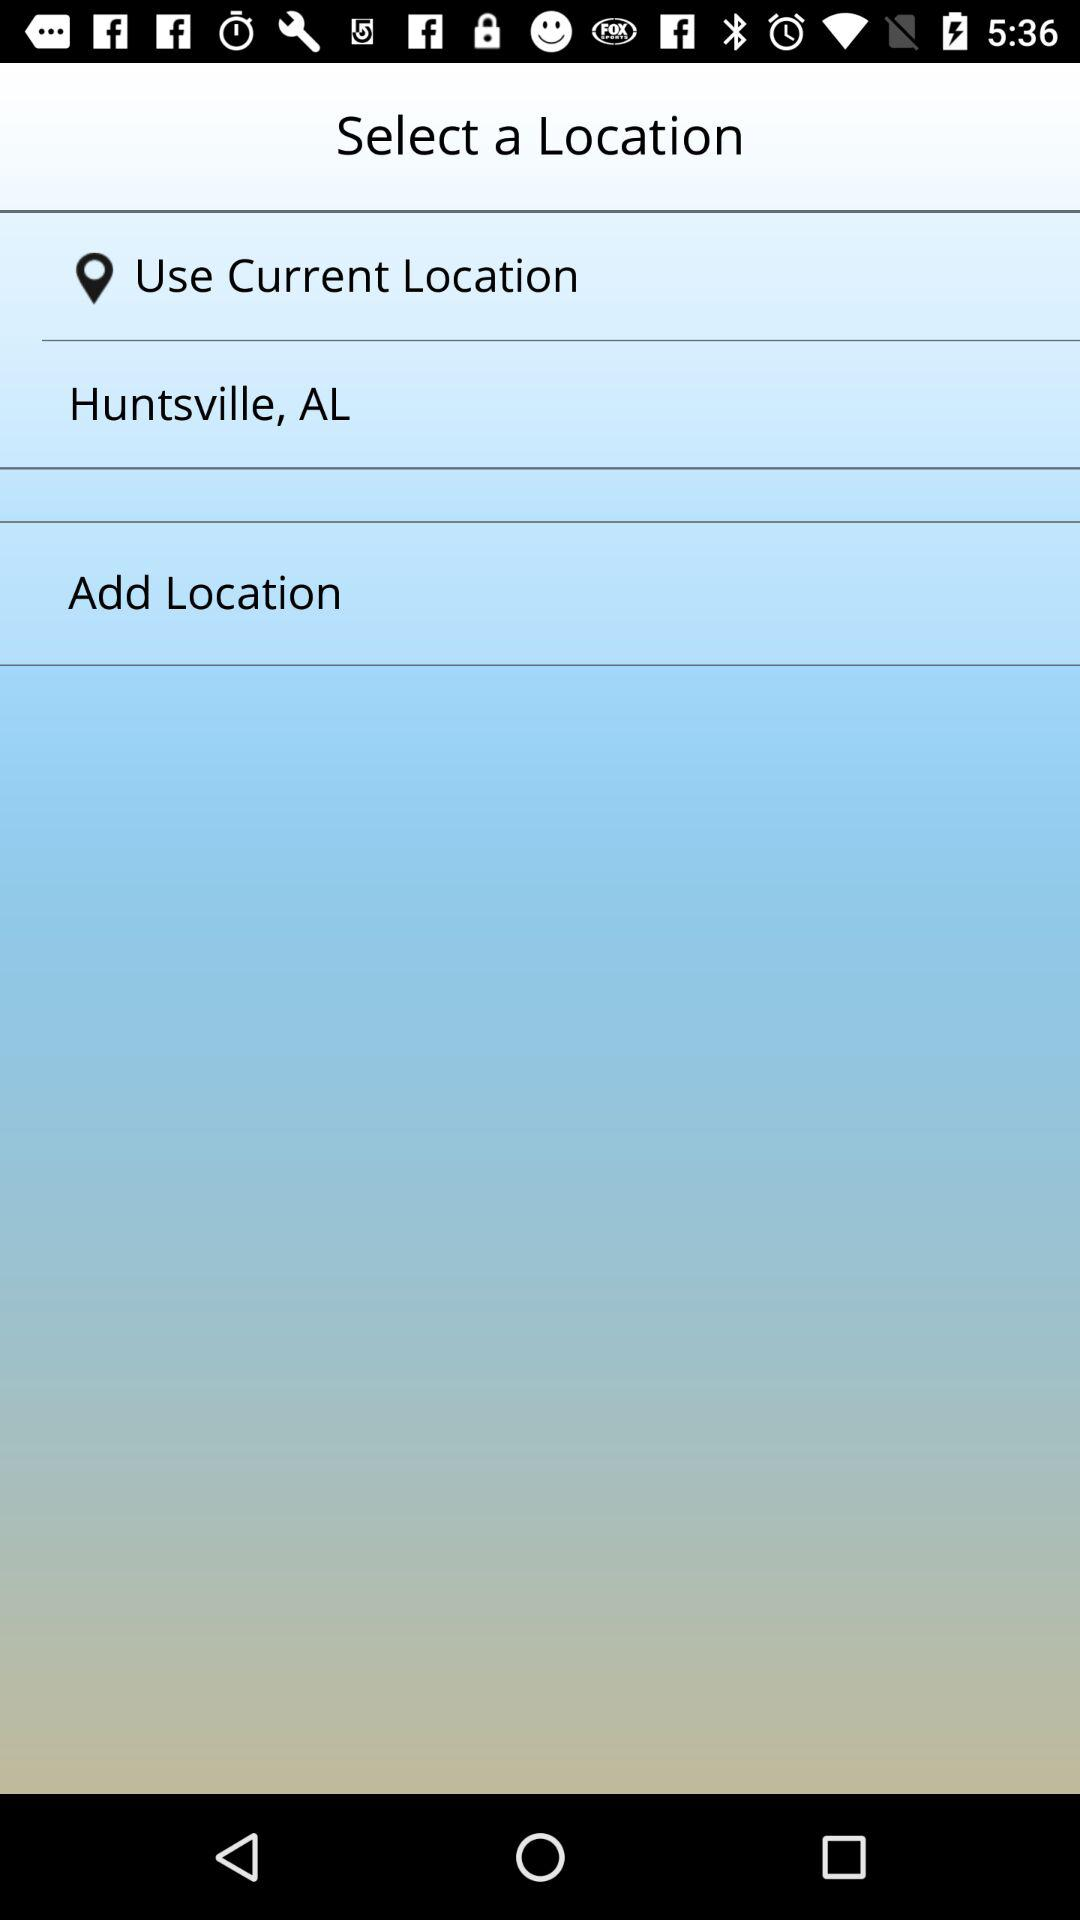What is the selected current location? The selected current location is Huntsville, AL. 